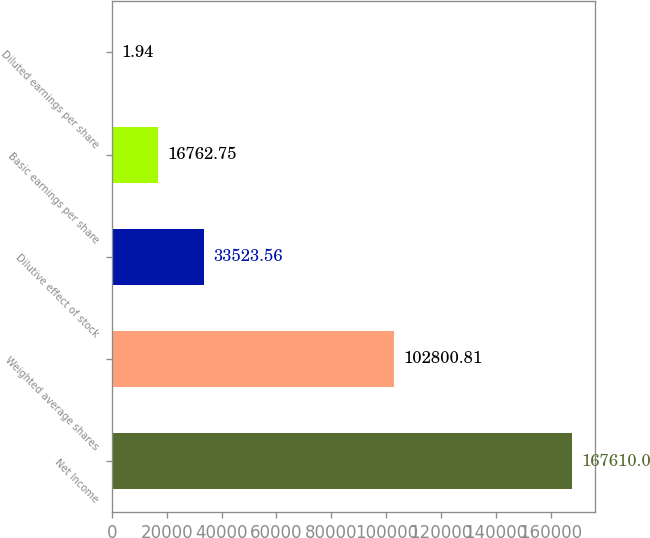Convert chart. <chart><loc_0><loc_0><loc_500><loc_500><bar_chart><fcel>Net Income<fcel>Weighted average shares<fcel>Dilutive effect of stock<fcel>Basic earnings per share<fcel>Diluted earnings per share<nl><fcel>167610<fcel>102801<fcel>33523.6<fcel>16762.8<fcel>1.94<nl></chart> 